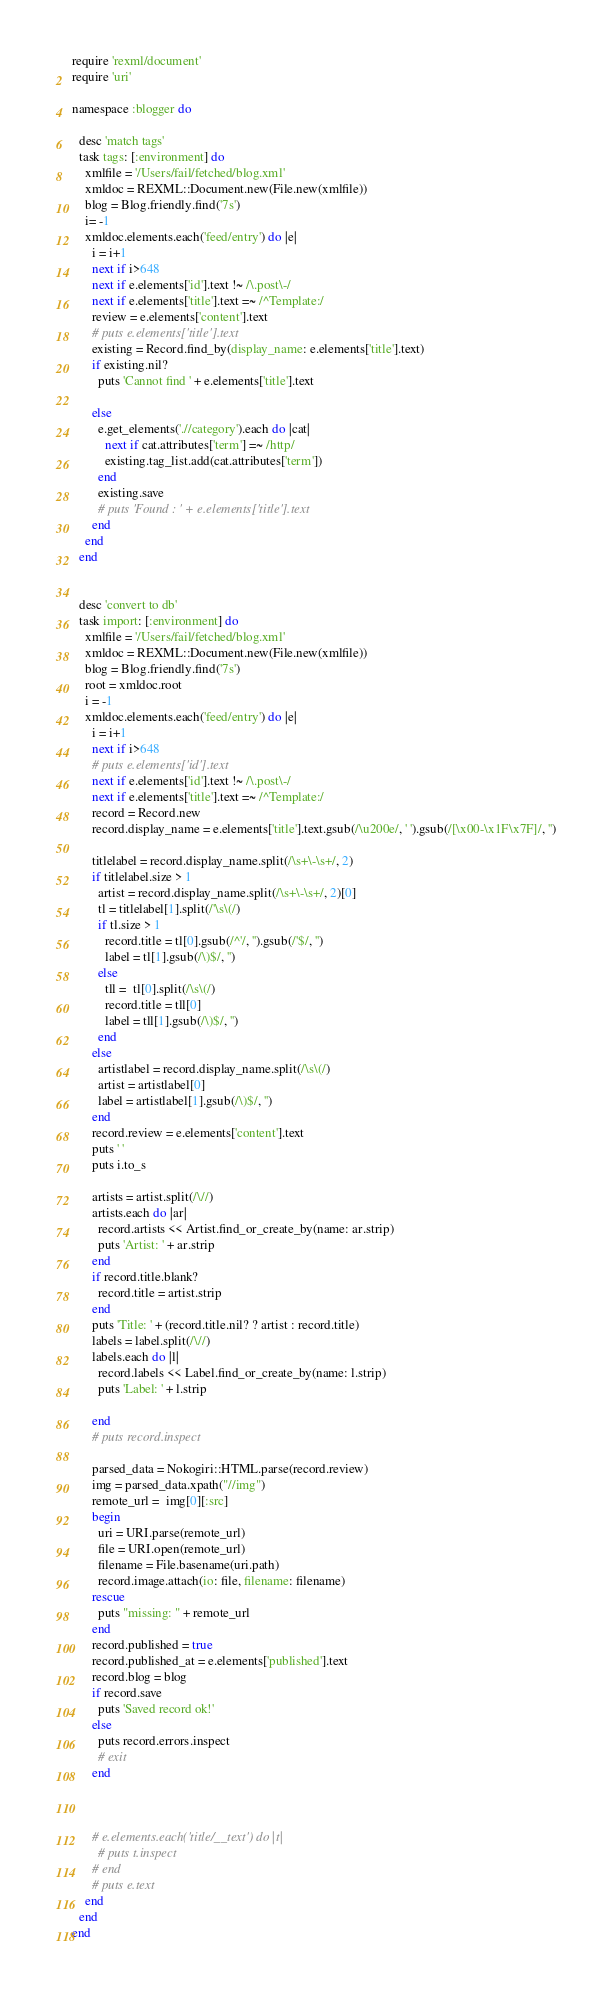Convert code to text. <code><loc_0><loc_0><loc_500><loc_500><_Ruby_>require 'rexml/document'
require 'uri'

namespace :blogger do

  desc 'match tags'
  task tags: [:environment] do
    xmlfile = '/Users/fail/fetched/blog.xml'
    xmldoc = REXML::Document.new(File.new(xmlfile))
    blog = Blog.friendly.find('7s')
    i= -1
    xmldoc.elements.each('feed/entry') do |e|
      i = i+1
      next if i>648
      next if e.elements['id'].text !~ /\.post\-/
      next if e.elements['title'].text =~ /^Template:/
      review = e.elements['content'].text
      # puts e.elements['title'].text
      existing = Record.find_by(display_name: e.elements['title'].text)
      if existing.nil?
        puts 'Cannot find ' + e.elements['title'].text

      else
        e.get_elements('.//category').each do |cat|
          next if cat.attributes['term'] =~ /http/
          existing.tag_list.add(cat.attributes['term'])
        end
        existing.save
        # puts 'Found : ' + e.elements['title'].text
      end
    end
  end


  desc 'convert to db'
  task import: [:environment] do
    xmlfile = '/Users/fail/fetched/blog.xml'
    xmldoc = REXML::Document.new(File.new(xmlfile))
    blog = Blog.friendly.find('7s')
    root = xmldoc.root
    i = -1
    xmldoc.elements.each('feed/entry') do |e|
      i = i+1
      next if i>648
      # puts e.elements['id'].text
      next if e.elements['id'].text !~ /\.post\-/
      next if e.elements['title'].text =~ /^Template:/
      record = Record.new
      record.display_name = e.elements['title'].text.gsub(/\u200e/, ' ').gsub(/[\x00-\x1F\x7F]/, '')
  
      titlelabel = record.display_name.split(/\s+\-\s+/, 2)
      if titlelabel.size > 1
        artist = record.display_name.split(/\s+\-\s+/, 2)[0]
        tl = titlelabel[1].split(/'\s\(/)
        if tl.size > 1
          record.title = tl[0].gsub(/^'/, '').gsub(/'$/, '')
          label = tl[1].gsub(/\)$/, '')
        else
          tll =  tl[0].split(/\s\(/)
          record.title = tll[0]
          label = tll[1].gsub(/\)$/, '')
        end
      else
        artistlabel = record.display_name.split(/\s\(/)
        artist = artistlabel[0]
        label = artistlabel[1].gsub(/\)$/, '')
      end
      record.review = e.elements['content'].text
      puts ' '
      puts i.to_s
      
      artists = artist.split(/\//)
      artists.each do |ar|
        record.artists << Artist.find_or_create_by(name: ar.strip)
        puts 'Artist: ' + ar.strip
      end
      if record.title.blank?
        record.title = artist.strip
      end
      puts 'Title: ' + (record.title.nil? ? artist : record.title)
      labels = label.split(/\//)
      labels.each do |l|
        record.labels << Label.find_or_create_by(name: l.strip)
        puts 'Label: ' + l.strip

      end
      # puts record.inspect

      parsed_data = Nokogiri::HTML.parse(record.review)
      img = parsed_data.xpath("//img")
      remote_url =  img[0][:src]
      begin
        uri = URI.parse(remote_url)
        file = URI.open(remote_url)
        filename = File.basename(uri.path)
        record.image.attach(io: file, filename: filename)
      rescue
        puts "missing: " + remote_url
      end
      record.published = true
      record.published_at = e.elements['published'].text
      record.blog = blog
      if record.save
        puts 'Saved record ok!'
      else
        puts record.errors.inspect
        # exit
      end


      
      # e.elements.each('title/__text') do |t|
        # puts t.inspect
      # end
      # puts e.text
    end
  end
end</code> 